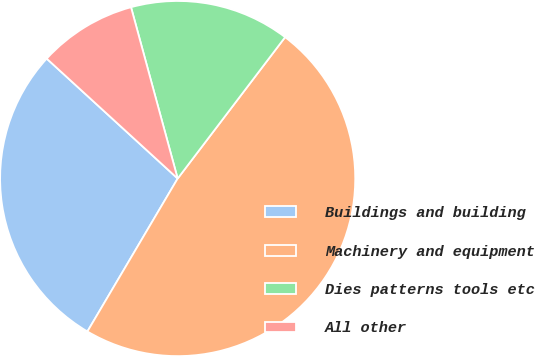<chart> <loc_0><loc_0><loc_500><loc_500><pie_chart><fcel>Buildings and building<fcel>Machinery and equipment<fcel>Dies patterns tools etc<fcel>All other<nl><fcel>28.31%<fcel>48.14%<fcel>14.57%<fcel>8.97%<nl></chart> 